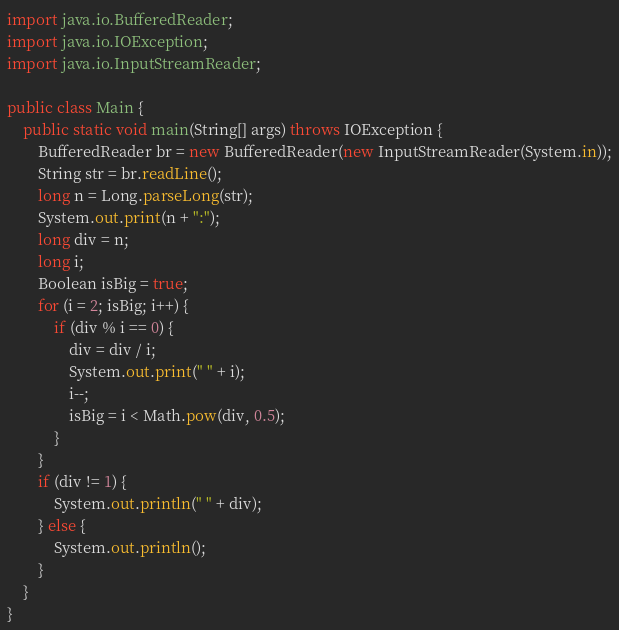Convert code to text. <code><loc_0><loc_0><loc_500><loc_500><_Java_>import java.io.BufferedReader;
import java.io.IOException;
import java.io.InputStreamReader;

public class Main {
	public static void main(String[] args) throws IOException {
		BufferedReader br = new BufferedReader(new InputStreamReader(System.in));
		String str = br.readLine();
		long n = Long.parseLong(str);
		System.out.print(n + ":");
		long div = n;
		long i;
		Boolean isBig = true;
		for (i = 2; isBig; i++) {
			if (div % i == 0) {
				div = div / i;
				System.out.print(" " + i);
				i--;
				isBig = i < Math.pow(div, 0.5);
			}
		}
		if (div != 1) {
			System.out.println(" " + div);
		} else {
			System.out.println();
		}
	}
}</code> 